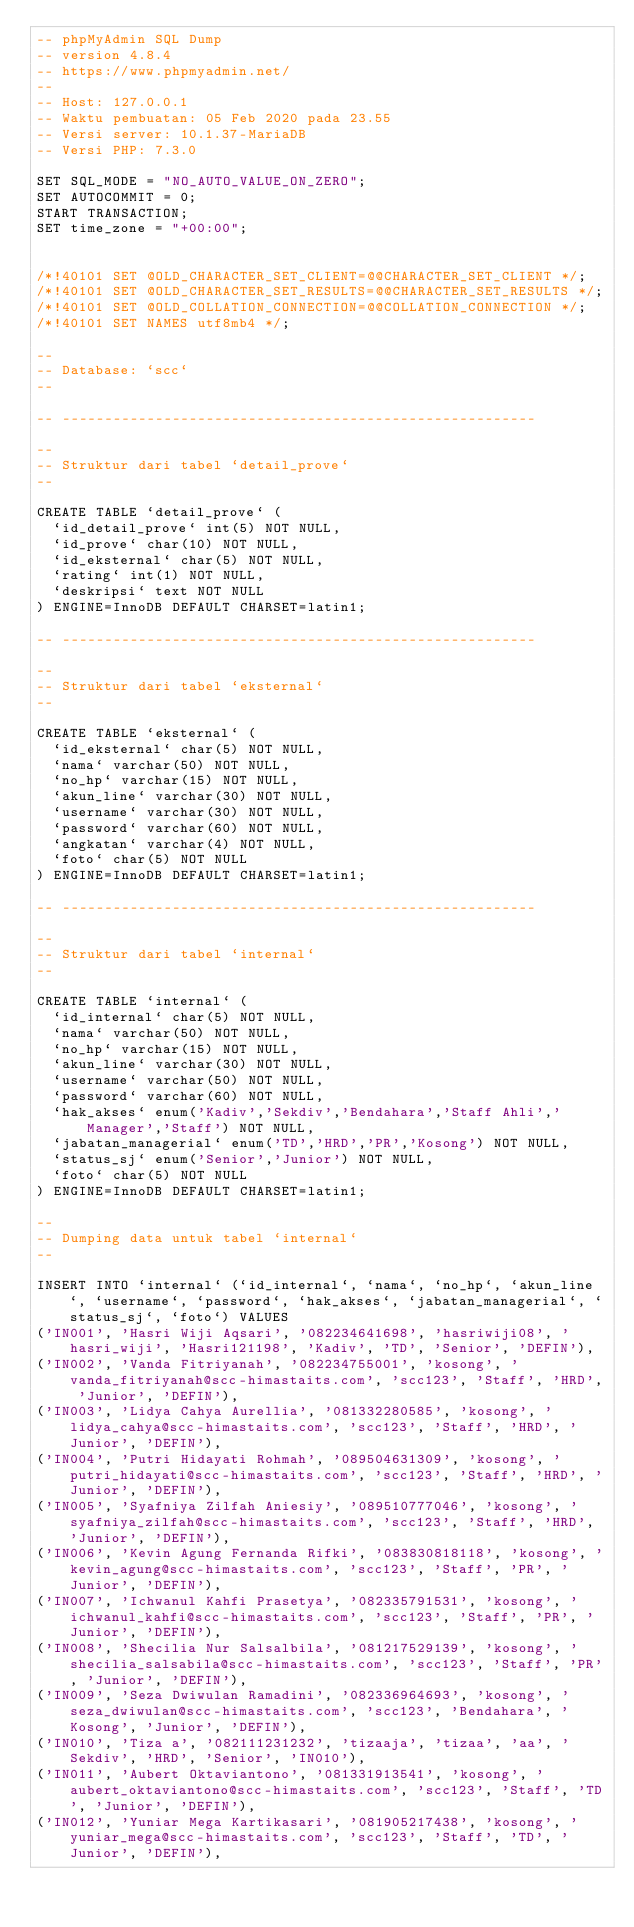Convert code to text. <code><loc_0><loc_0><loc_500><loc_500><_SQL_>-- phpMyAdmin SQL Dump
-- version 4.8.4
-- https://www.phpmyadmin.net/
--
-- Host: 127.0.0.1
-- Waktu pembuatan: 05 Feb 2020 pada 23.55
-- Versi server: 10.1.37-MariaDB
-- Versi PHP: 7.3.0

SET SQL_MODE = "NO_AUTO_VALUE_ON_ZERO";
SET AUTOCOMMIT = 0;
START TRANSACTION;
SET time_zone = "+00:00";


/*!40101 SET @OLD_CHARACTER_SET_CLIENT=@@CHARACTER_SET_CLIENT */;
/*!40101 SET @OLD_CHARACTER_SET_RESULTS=@@CHARACTER_SET_RESULTS */;
/*!40101 SET @OLD_COLLATION_CONNECTION=@@COLLATION_CONNECTION */;
/*!40101 SET NAMES utf8mb4 */;

--
-- Database: `scc`
--

-- --------------------------------------------------------

--
-- Struktur dari tabel `detail_prove`
--

CREATE TABLE `detail_prove` (
  `id_detail_prove` int(5) NOT NULL,
  `id_prove` char(10) NOT NULL,
  `id_eksternal` char(5) NOT NULL,
  `rating` int(1) NOT NULL,
  `deskripsi` text NOT NULL
) ENGINE=InnoDB DEFAULT CHARSET=latin1;

-- --------------------------------------------------------

--
-- Struktur dari tabel `eksternal`
--

CREATE TABLE `eksternal` (
  `id_eksternal` char(5) NOT NULL,
  `nama` varchar(50) NOT NULL,
  `no_hp` varchar(15) NOT NULL,
  `akun_line` varchar(30) NOT NULL,
  `username` varchar(30) NOT NULL,
  `password` varchar(60) NOT NULL,
  `angkatan` varchar(4) NOT NULL,
  `foto` char(5) NOT NULL
) ENGINE=InnoDB DEFAULT CHARSET=latin1;

-- --------------------------------------------------------

--
-- Struktur dari tabel `internal`
--

CREATE TABLE `internal` (
  `id_internal` char(5) NOT NULL,
  `nama` varchar(50) NOT NULL,
  `no_hp` varchar(15) NOT NULL,
  `akun_line` varchar(30) NOT NULL,
  `username` varchar(50) NOT NULL,
  `password` varchar(60) NOT NULL,
  `hak_akses` enum('Kadiv','Sekdiv','Bendahara','Staff Ahli','Manager','Staff') NOT NULL,
  `jabatan_managerial` enum('TD','HRD','PR','Kosong') NOT NULL,
  `status_sj` enum('Senior','Junior') NOT NULL,
  `foto` char(5) NOT NULL
) ENGINE=InnoDB DEFAULT CHARSET=latin1;

--
-- Dumping data untuk tabel `internal`
--

INSERT INTO `internal` (`id_internal`, `nama`, `no_hp`, `akun_line`, `username`, `password`, `hak_akses`, `jabatan_managerial`, `status_sj`, `foto`) VALUES
('IN001', 'Hasri Wiji Aqsari', '082234641698', 'hasriwiji08', 'hasri_wiji', 'Hasri121198', 'Kadiv', 'TD', 'Senior', 'DEFIN'),
('IN002', 'Vanda Fitriyanah', '082234755001', 'kosong', 'vanda_fitriyanah@scc-himastaits.com', 'scc123', 'Staff', 'HRD', 'Junior', 'DEFIN'),
('IN003', 'Lidya Cahya Aurellia', '081332280585', 'kosong', 'lidya_cahya@scc-himastaits.com', 'scc123', 'Staff', 'HRD', 'Junior', 'DEFIN'),
('IN004', 'Putri Hidayati Rohmah', '089504631309', 'kosong', 'putri_hidayati@scc-himastaits.com', 'scc123', 'Staff', 'HRD', 'Junior', 'DEFIN'),
('IN005', 'Syafniya Zilfah Aniesiy', '089510777046', 'kosong', 'syafniya_zilfah@scc-himastaits.com', 'scc123', 'Staff', 'HRD', 'Junior', 'DEFIN'),
('IN006', 'Kevin Agung Fernanda Rifki', '083830818118', 'kosong', 'kevin_agung@scc-himastaits.com', 'scc123', 'Staff', 'PR', 'Junior', 'DEFIN'),
('IN007', 'Ichwanul Kahfi Prasetya', '082335791531', 'kosong', 'ichwanul_kahfi@scc-himastaits.com', 'scc123', 'Staff', 'PR', 'Junior', 'DEFIN'),
('IN008', 'Shecilia Nur Salsalbila', '081217529139', 'kosong', 'shecilia_salsabila@scc-himastaits.com', 'scc123', 'Staff', 'PR', 'Junior', 'DEFIN'),
('IN009', 'Seza Dwiwulan Ramadini', '082336964693', 'kosong', 'seza_dwiwulan@scc-himastaits.com', 'scc123', 'Bendahara', 'Kosong', 'Junior', 'DEFIN'),
('IN010', 'Tiza a', '082111231232', 'tizaaja', 'tizaa', 'aa', 'Sekdiv', 'HRD', 'Senior', 'IN010'),
('IN011', 'Aubert Oktaviantono', '081331913541', 'kosong', 'aubert_oktaviantono@scc-himastaits.com', 'scc123', 'Staff', 'TD', 'Junior', 'DEFIN'),
('IN012', 'Yuniar Mega Kartikasari', '081905217438', 'kosong', 'yuniar_mega@scc-himastaits.com', 'scc123', 'Staff', 'TD', 'Junior', 'DEFIN'),</code> 